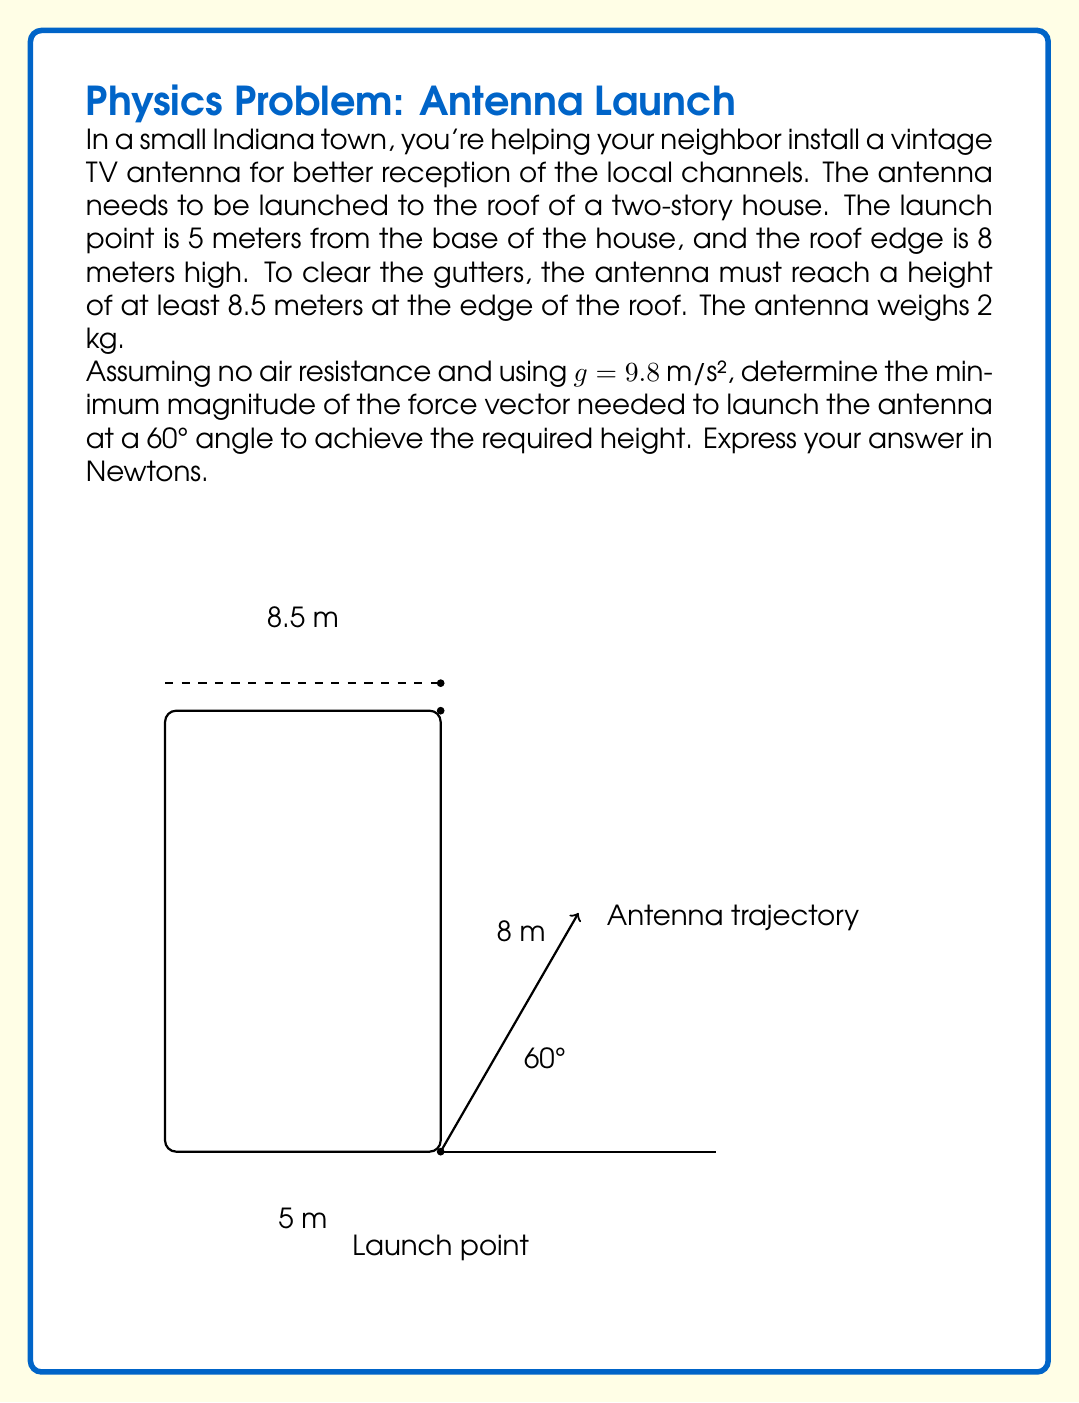Help me with this question. Let's approach this step-by-step:

1) First, we need to find the time it takes for the antenna to reach the edge of the roof. We can use the horizontal component of motion for this:

   $x = v_0 \cos(\theta) t$
   $5 = v_0 \cos(60°) t$
   $t = \frac{5}{v_0 \cos(60°)} = \frac{10}{v_0}$ (since $\cos(60°) = 0.5$)

2) Now, we can use this time in the vertical component equation to find the initial velocity needed:

   $y = v_0 \sin(\theta) t - \frac{1}{2}gt^2$
   $8.5 = v_0 \sin(60°) (\frac{10}{v_0}) - \frac{1}{2}(9.8)(\frac{10}{v_0})^2$
   $8.5 = 10\sin(60°) - 490v_0^{-2}$
   $8.5 = 10(0.866) - 490v_0^{-2}$
   $8.5 = 8.66 - 490v_0^{-2}$
   $490v_0^{-2} = 0.16$
   $v_0^2 = 3062.5$
   $v_0 = \sqrt{3062.5} \approx 55.34$ m/s

3) Now that we have the initial velocity, we can calculate the force needed using Newton's Second Law:

   $F = ma$

   We need to find the acceleration. In a launch scenario, we can consider the acceleration as the change in velocity over a very short time. Let's assume the launch happens over 0.1 seconds:

   $a = \frac{\Delta v}{\Delta t} = \frac{55.34}{0.1} = 553.4$ m/s²

4) Now we can calculate the force:

   $F = (2 \text{ kg})(553.4 \text{ m/s²}) = 1106.8$ N

Therefore, the minimum force needed is approximately 1106.8 N.
Answer: $1106.8 \text{ N}$ 